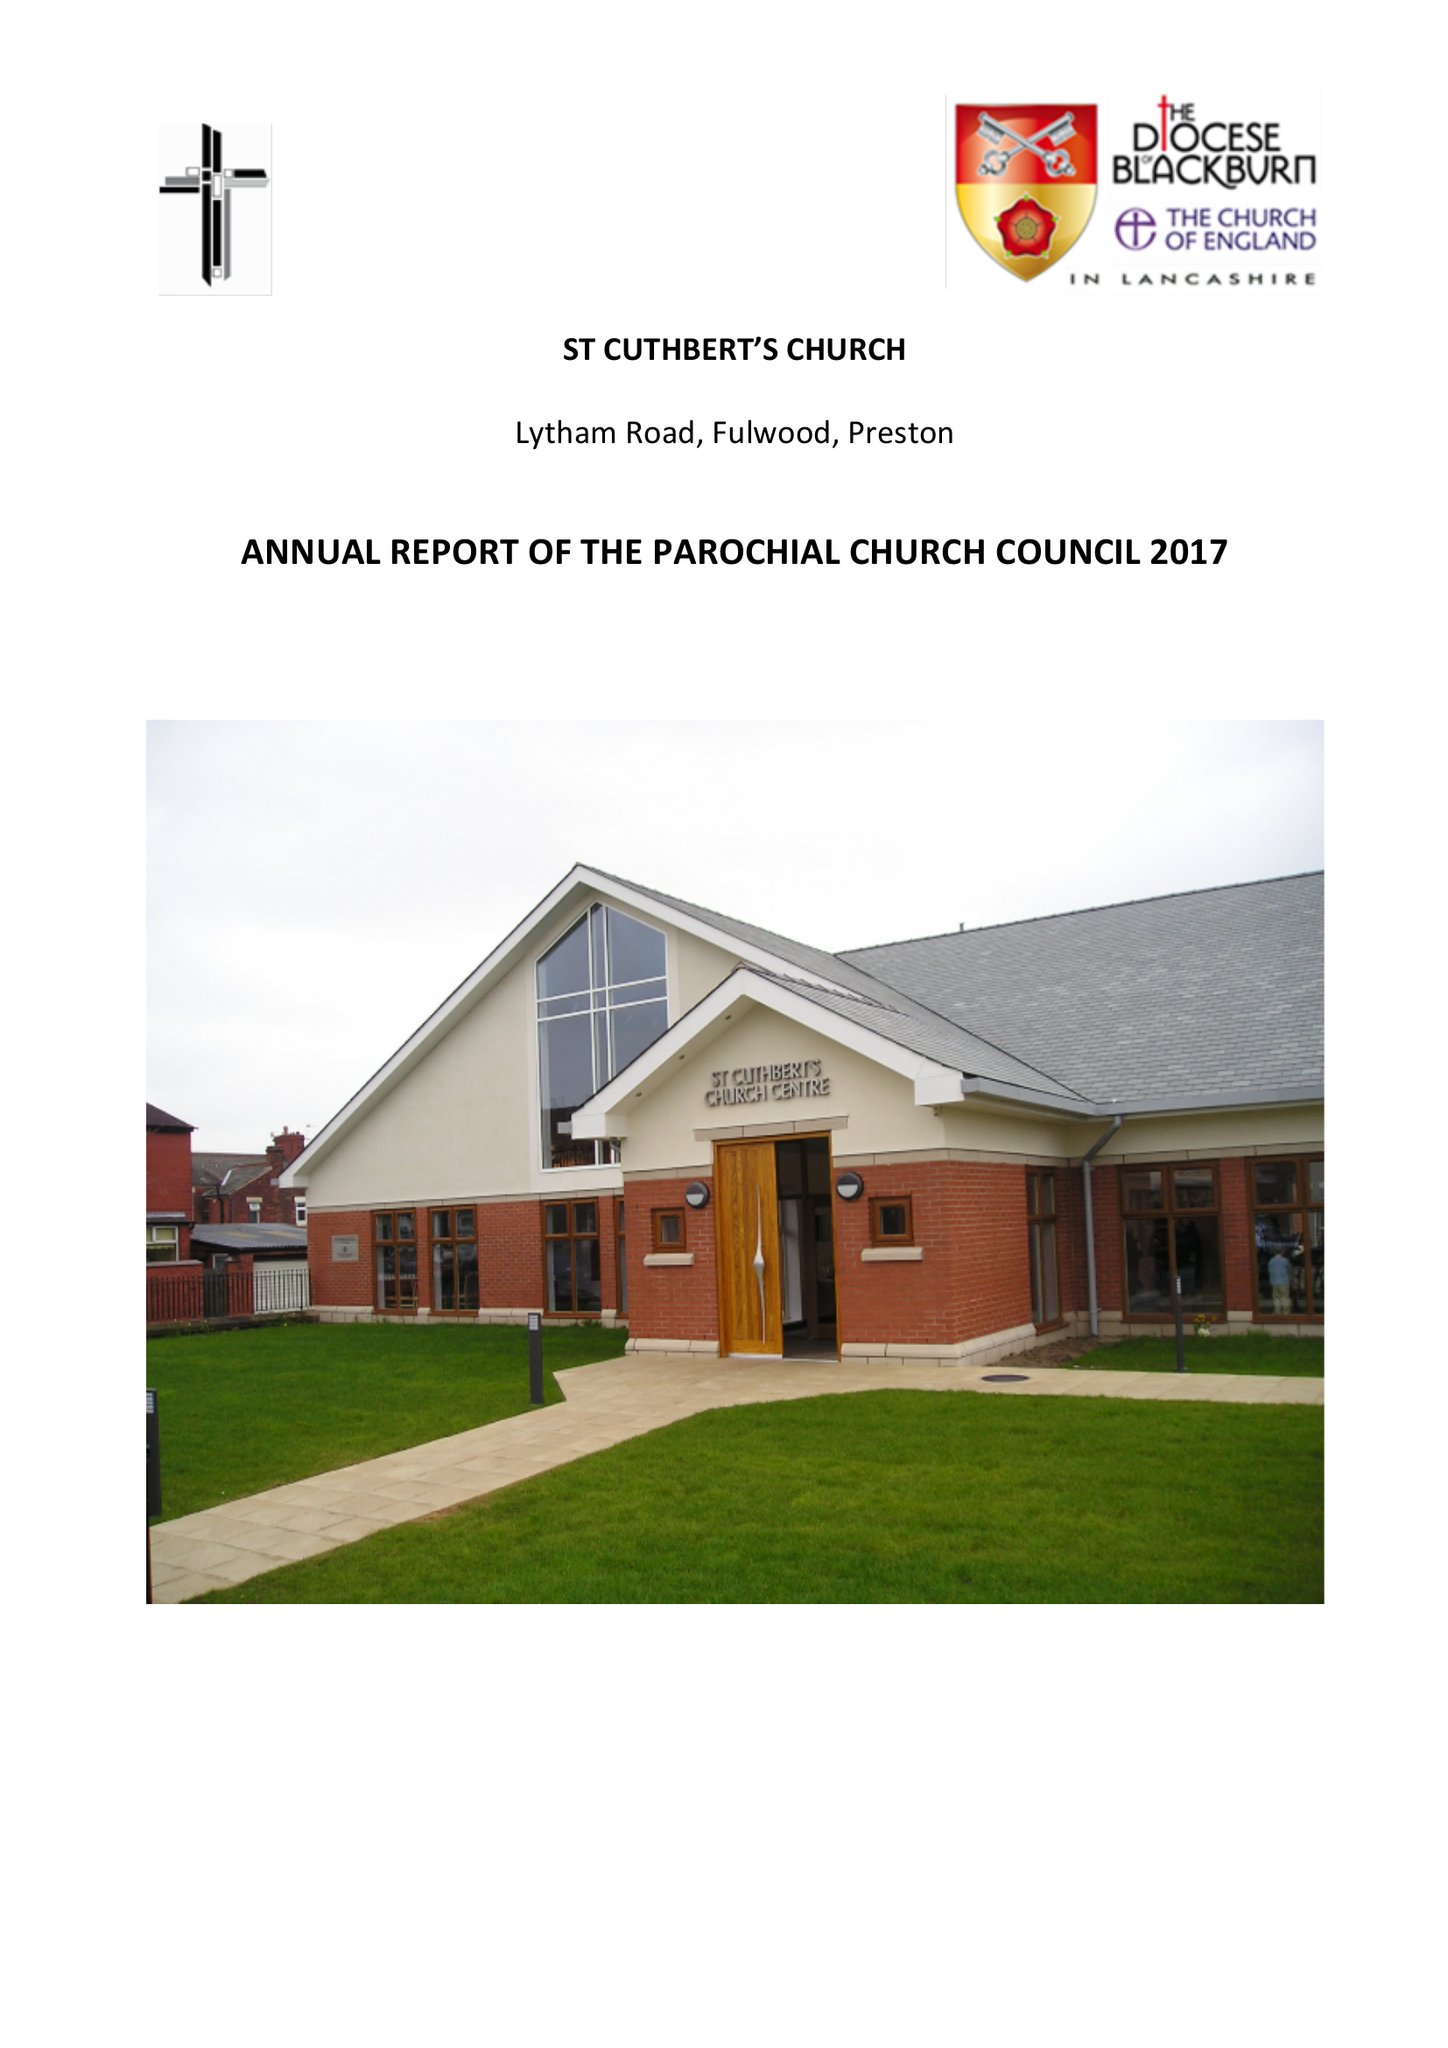What is the value for the charity_number?
Answer the question using a single word or phrase. 1127997 